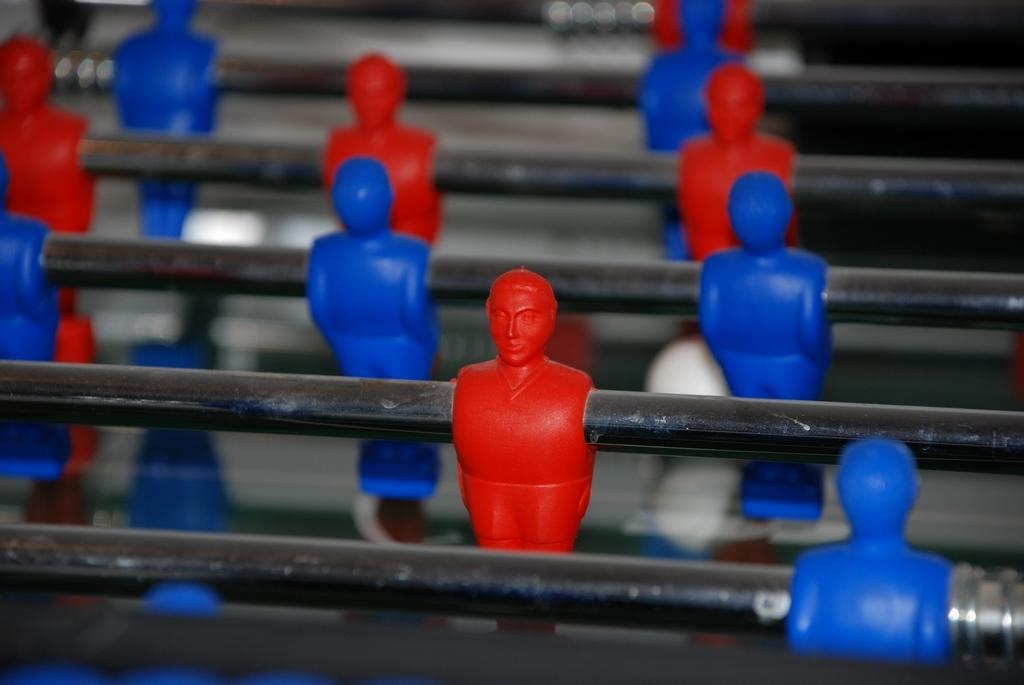Please provide a concise description of this image. In this picture we can see some red and blue toys to the iron rods. 